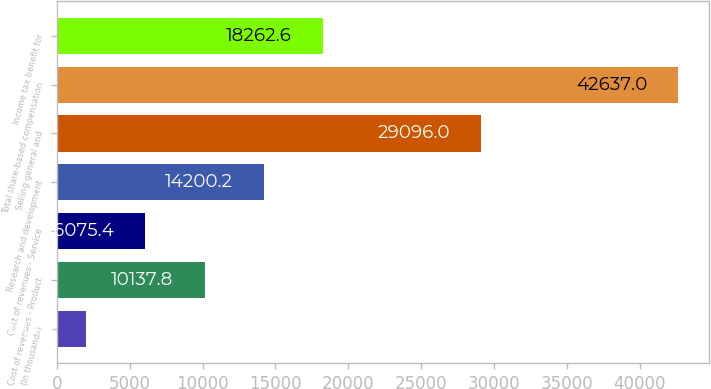Convert chart to OTSL. <chart><loc_0><loc_0><loc_500><loc_500><bar_chart><fcel>(In thousands)<fcel>Cost of revenues - Product<fcel>Cost of revenues - Service<fcel>Research and development<fcel>Selling general and<fcel>Total share-based compensation<fcel>Income tax benefit for<nl><fcel>2013<fcel>10137.8<fcel>6075.4<fcel>14200.2<fcel>29096<fcel>42637<fcel>18262.6<nl></chart> 